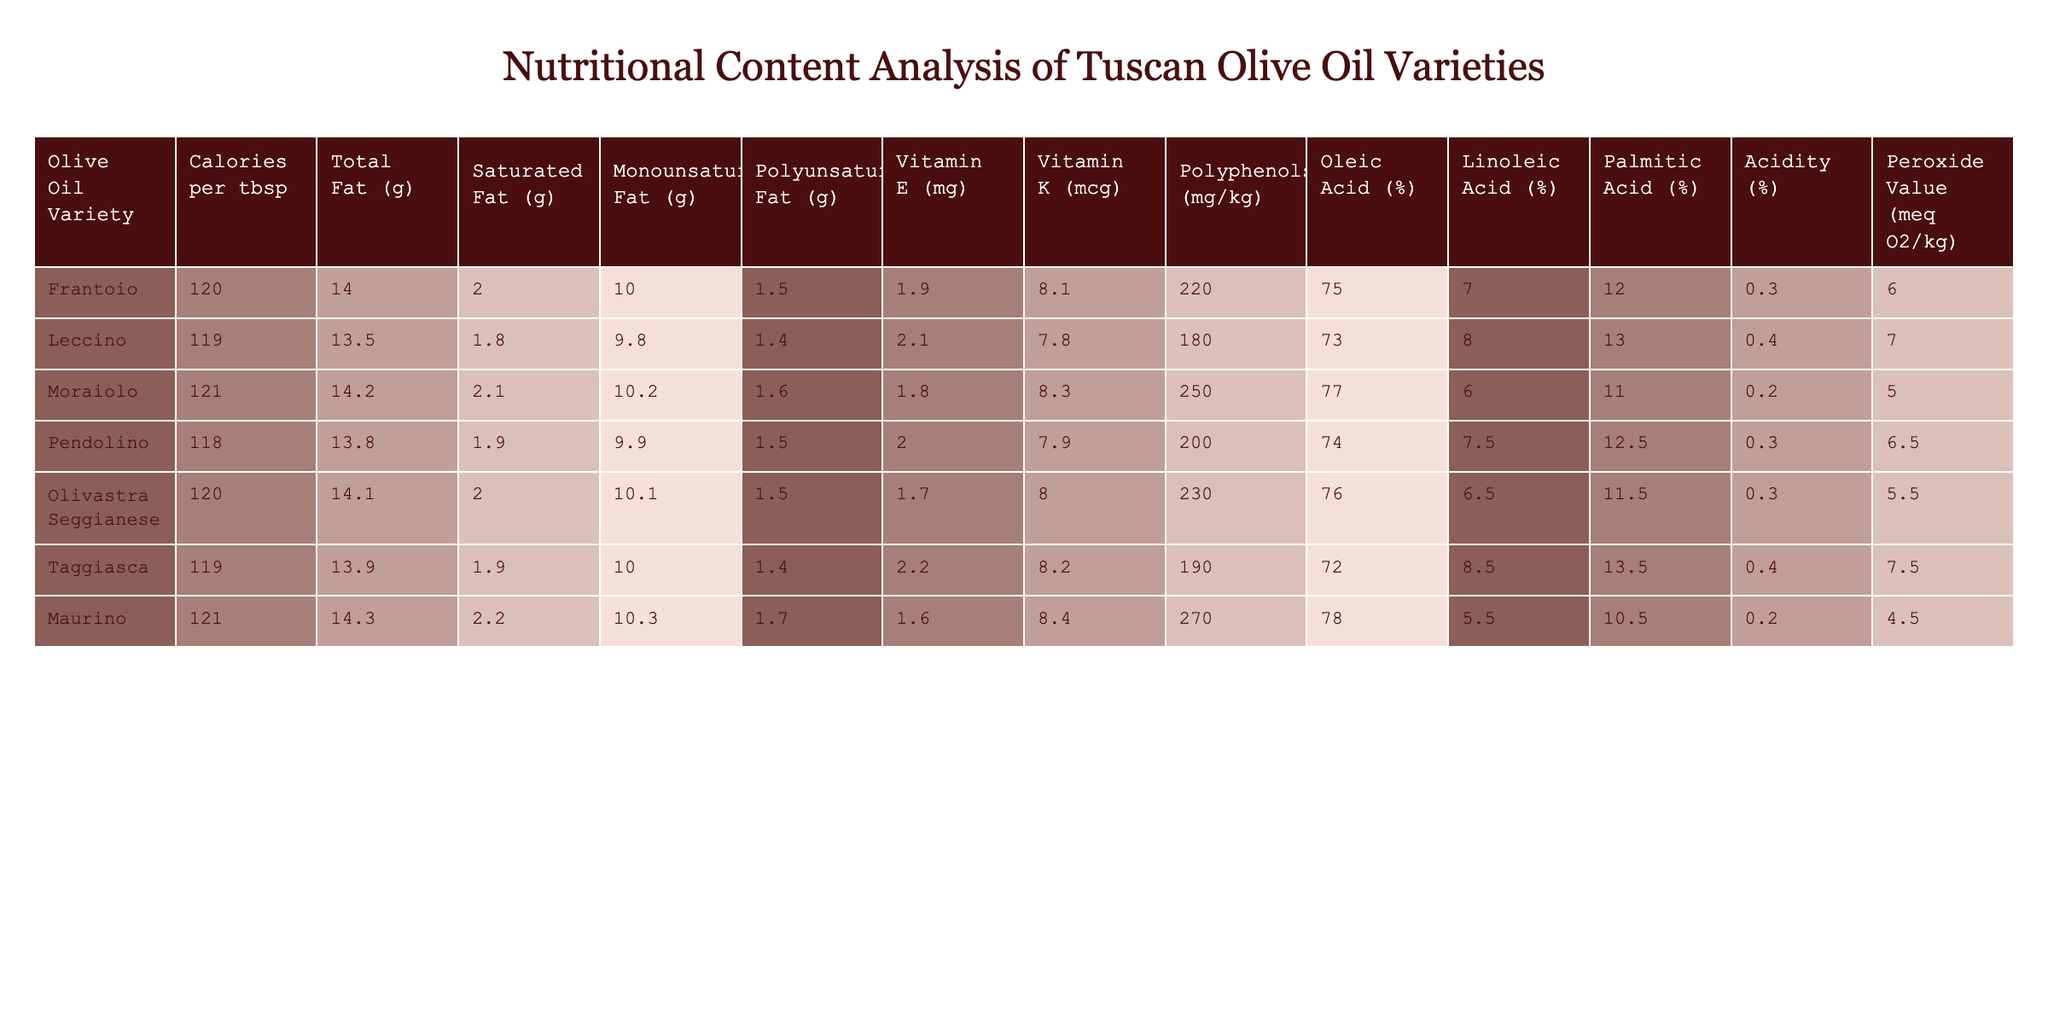What is the variety with the highest calorie content per tablespoon? According to the table, the variety with the highest calorie content is Moraiolo, with 121 calories per tablespoon.
Answer: Moraiolo Which olive oil contains the least saturated fat? By examining the Saturated Fat column, we can see that Leccino has the least amount of saturated fat at 1.8 grams.
Answer: Leccino What is the average oleic acid percentage across all varieties? To find the average oleic acid percentage, we add the oleic acid values: (75 + 73 + 77 + 74 + 76 + 72 + 78) = 525. There are 7 varieties, so the average is 525/7 = 75.
Answer: 75 Does the Pendolino variety have more vitamin E than the Moraiolo variety? Looking at the Vitamin E values, Pendolino has 2.0 mg while Moraiolo has 1.8 mg. Thus, Pendolino has more vitamin E than Moraiolo.
Answer: Yes Which olive oil variety has the highest acidity? The Acidity column shows that Moraiolo and Maurino both have the highest acidity at 0.2%. This indicates that they have an equal amount of acidity.
Answer: Moraiolo and Maurino What is the difference in total fat between the Frantoio and Leccino varieties? To find the difference in total fat, subtract the total fat content of Leccino (13.5 g) from Frantoio (14 g): 14 - 13.5 = 0.5 g.
Answer: 0.5 g Which olive oil has the highest polyphenols content? Upon reviewing the Polyphenols column, Maurino has the highest content at 270 mg/kg.
Answer: Maurino Is the peroxide value of Olivastra Seggianese greater than that of Pendolino? By comparing the Peroxide Values, Olivastra Seggianese has 5.5 meq O2/kg while Pendolino has 6.5 meq O2/kg. This indicates that Olivastra Seggianese has a lower peroxide value than Pendolino.
Answer: No 